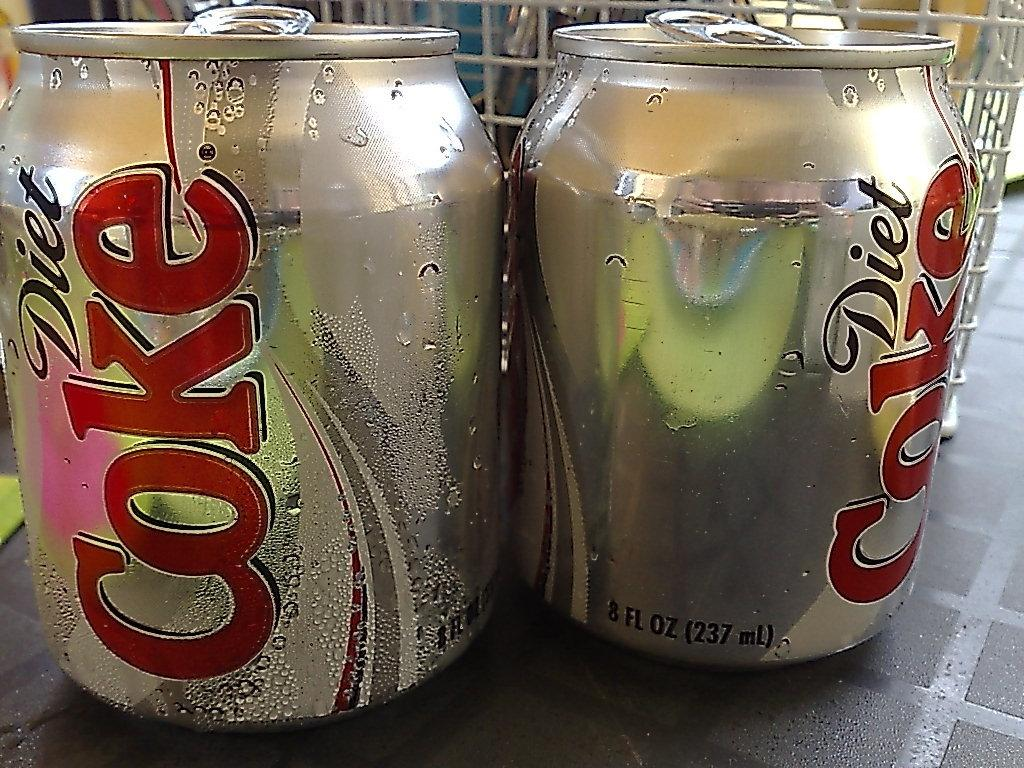<image>
Provide a brief description of the given image. Two 8 FL OZ cans of Diet Coke. 